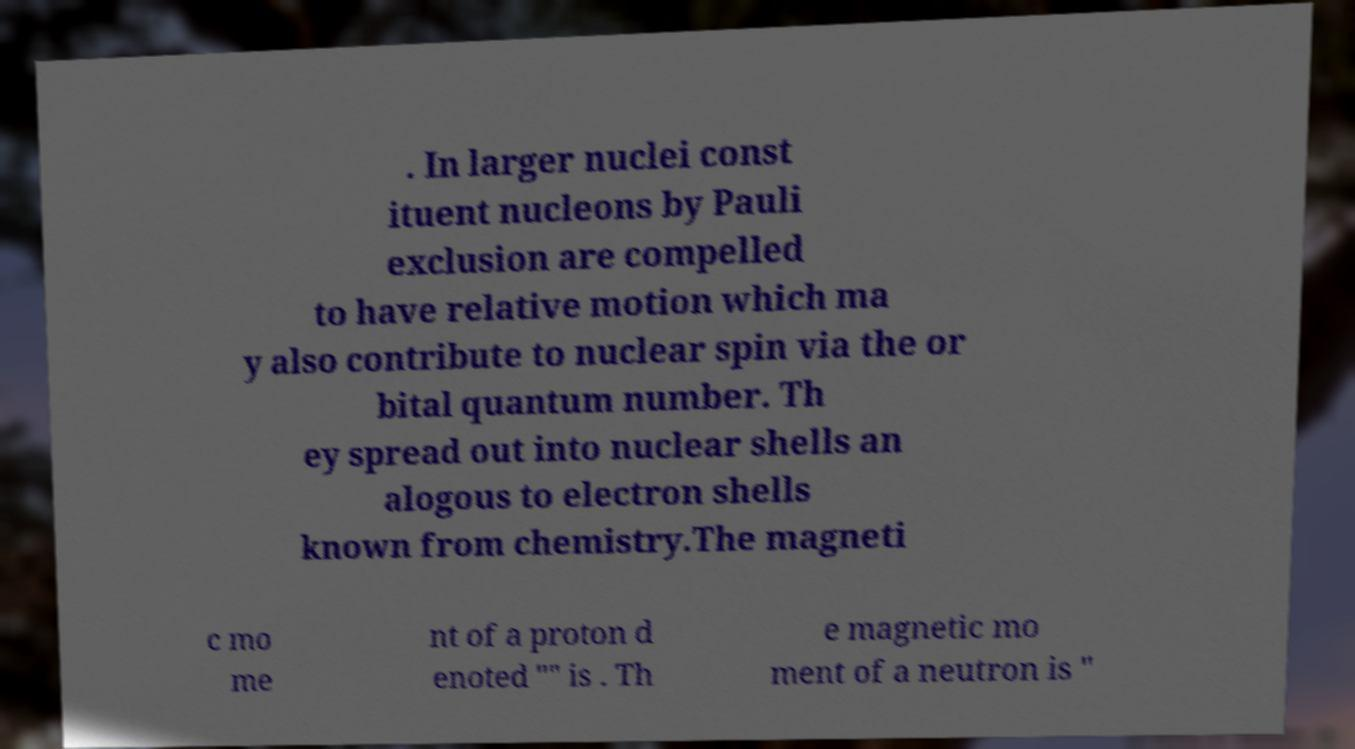Could you assist in decoding the text presented in this image and type it out clearly? . In larger nuclei const ituent nucleons by Pauli exclusion are compelled to have relative motion which ma y also contribute to nuclear spin via the or bital quantum number. Th ey spread out into nuclear shells an alogous to electron shells known from chemistry.The magneti c mo me nt of a proton d enoted "" is . Th e magnetic mo ment of a neutron is " 